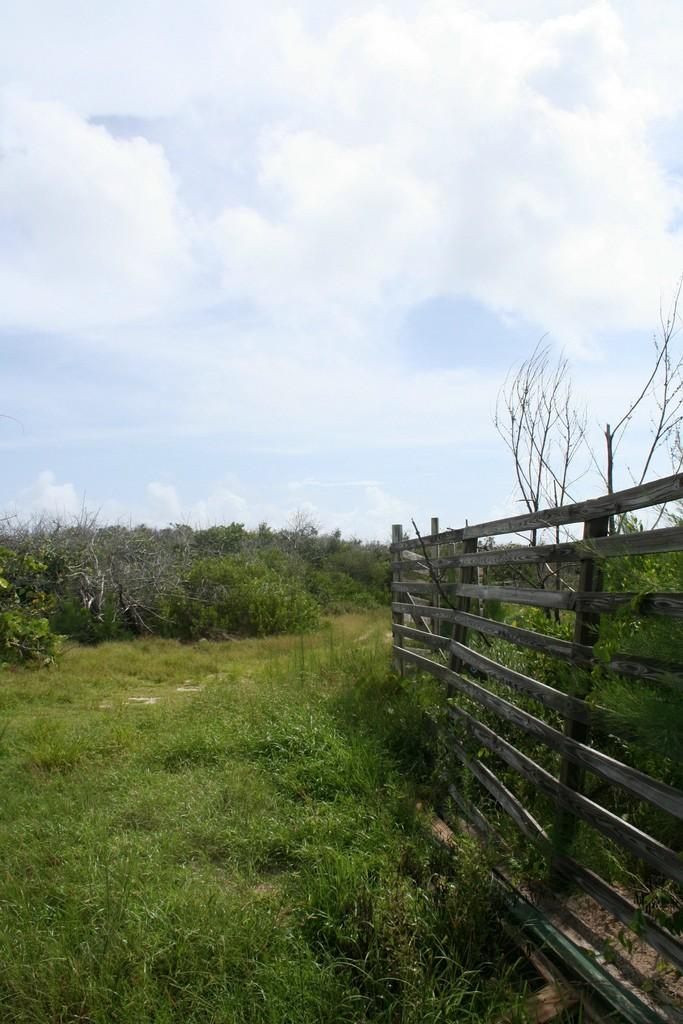What type of barrier can be seen in the image? There is a fence in the image. What type of vegetation is present in the image? There is grass in the image. What other natural elements can be seen in the image? There are trees in the image. What is visible in the background of the image? The sky is visible in the background of the image. Where is the pot located in the image? There is no pot present in the image. What type of calendar is hanging on the trees in the image? There is no calendar present in the image. 